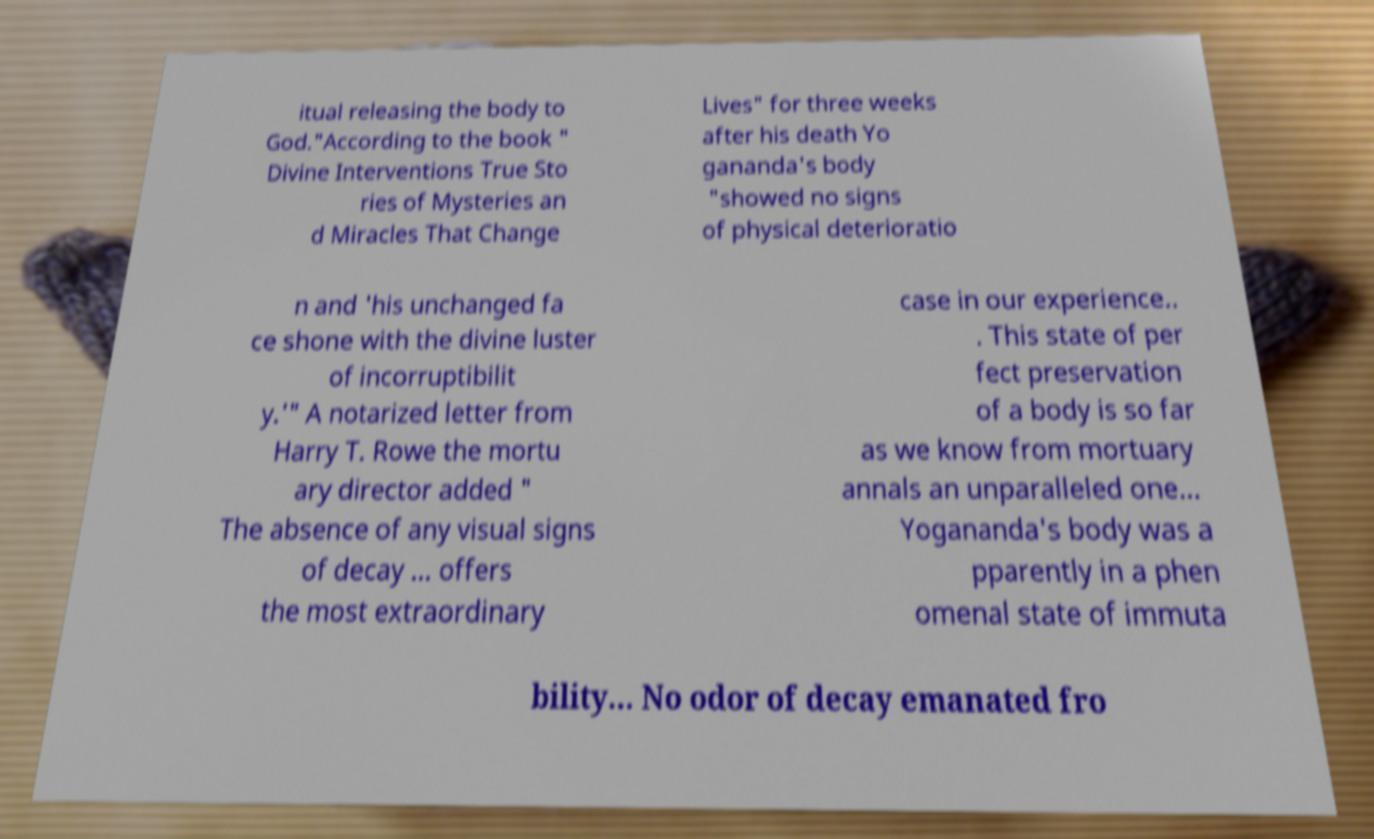For documentation purposes, I need the text within this image transcribed. Could you provide that? itual releasing the body to God."According to the book " Divine Interventions True Sto ries of Mysteries an d Miracles That Change Lives" for three weeks after his death Yo gananda's body "showed no signs of physical deterioratio n and 'his unchanged fa ce shone with the divine luster of incorruptibilit y.'" A notarized letter from Harry T. Rowe the mortu ary director added " The absence of any visual signs of decay … offers the most extraordinary case in our experience.. . This state of per fect preservation of a body is so far as we know from mortuary annals an unparalleled one... Yogananda's body was a pparently in a phen omenal state of immuta bility... No odor of decay emanated fro 